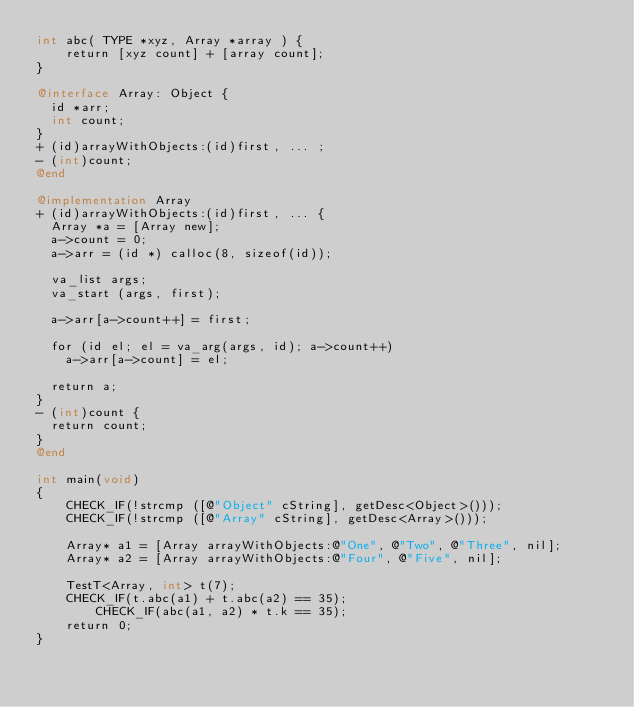<code> <loc_0><loc_0><loc_500><loc_500><_ObjectiveC_>int abc( TYPE *xyz, Array *array ) {
	return [xyz count] + [array count];
}

@interface Array: Object {
  id *arr;
  int count;
}
+ (id)arrayWithObjects:(id)first, ... ;
- (int)count;
@end

@implementation Array
+ (id)arrayWithObjects:(id)first, ... {
  Array *a = [Array new];
  a->count = 0;
  a->arr = (id *) calloc(8, sizeof(id));

  va_list args;
  va_start (args, first);
  
  a->arr[a->count++] = first;

  for (id el; el = va_arg(args, id); a->count++)
    a->arr[a->count] = el;

  return a;
}
- (int)count {
  return count;
}
@end

int main(void)
{
	CHECK_IF(!strcmp ([@"Object" cString], getDesc<Object>()));
	CHECK_IF(!strcmp ([@"Array" cString], getDesc<Array>()));

	Array* a1 = [Array arrayWithObjects:@"One", @"Two", @"Three", nil];
	Array* a2 = [Array arrayWithObjects:@"Four", @"Five", nil];

	TestT<Array, int> t(7);
	CHECK_IF(t.abc(a1) + t.abc(a2) == 35);
        CHECK_IF(abc(a1, a2) * t.k == 35);
	return 0;
}
</code> 